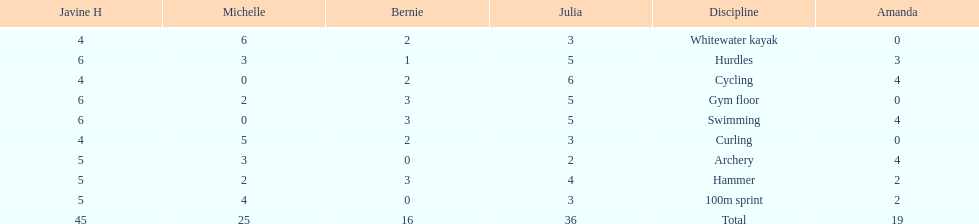What other girl besides amanda also had a 4 in cycling? Javine H. Write the full table. {'header': ['Javine H', 'Michelle', 'Bernie', 'Julia', 'Discipline', 'Amanda'], 'rows': [['4', '6', '2', '3', 'Whitewater kayak', '0'], ['6', '3', '1', '5', 'Hurdles', '3'], ['4', '0', '2', '6', 'Cycling', '4'], ['6', '2', '3', '5', 'Gym floor', '0'], ['6', '0', '3', '5', 'Swimming', '4'], ['4', '5', '2', '3', 'Curling', '0'], ['5', '3', '0', '2', 'Archery', '4'], ['5', '2', '3', '4', 'Hammer', '2'], ['5', '4', '0', '3', '100m sprint', '2'], ['45', '25', '16', '36', 'Total', '19']]} 